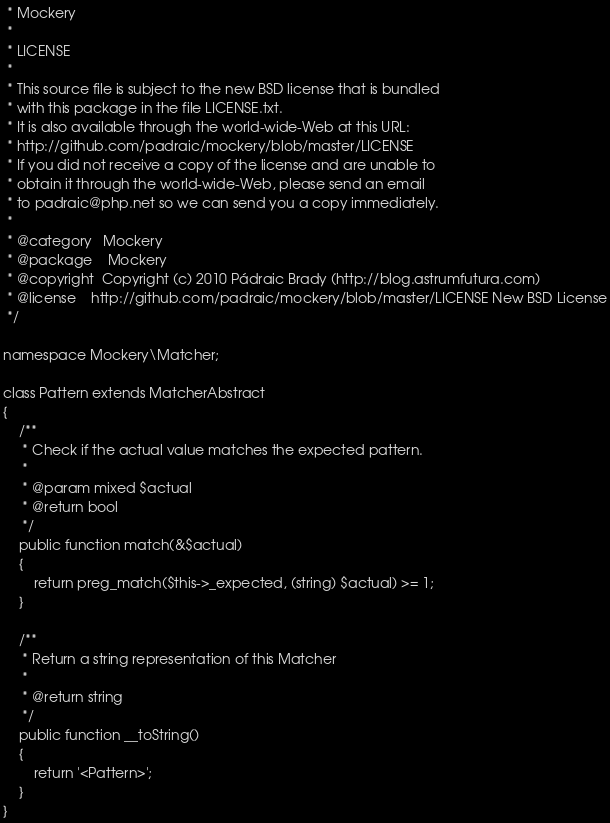<code> <loc_0><loc_0><loc_500><loc_500><_PHP_> * Mockery
 *
 * LICENSE
 *
 * This source file is subject to the new BSD license that is bundled
 * with this package in the file LICENSE.txt.
 * It is also available through the world-wide-Web at this URL:
 * http://github.com/padraic/mockery/blob/master/LICENSE
 * If you did not receive a copy of the license and are unable to
 * obtain it through the world-wide-Web, please send an email
 * to padraic@php.net so we can send you a copy immediately.
 *
 * @category   Mockery
 * @package    Mockery
 * @copyright  Copyright (c) 2010 Pádraic Brady (http://blog.astrumfutura.com)
 * @license    http://github.com/padraic/mockery/blob/master/LICENSE New BSD License
 */

namespace Mockery\Matcher;

class Pattern extends MatcherAbstract
{
    /**
     * Check if the actual value matches the expected pattern.
     *
     * @param mixed $actual
     * @return bool
     */
    public function match(&$actual)
    {
        return preg_match($this->_expected, (string) $actual) >= 1;
    }

    /**
     * Return a string representation of this Matcher
     *
     * @return string
     */
    public function __toString()
    {
        return '<Pattern>';
    }
}
</code> 